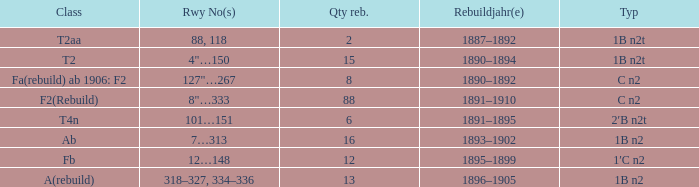What is the type if quantity rebuilt is more than 2 and the railway number is 4"…150? 1B n2t. 